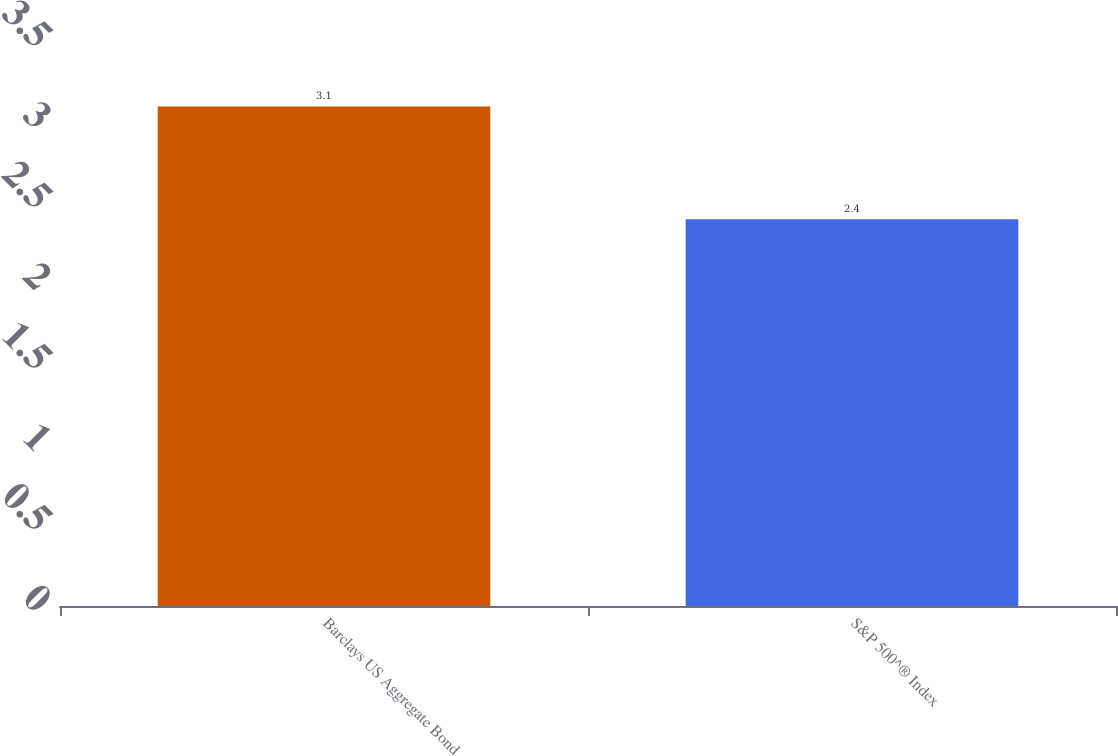<chart> <loc_0><loc_0><loc_500><loc_500><bar_chart><fcel>Barclays US Aggregate Bond<fcel>S&P 500^® Index<nl><fcel>3.1<fcel>2.4<nl></chart> 